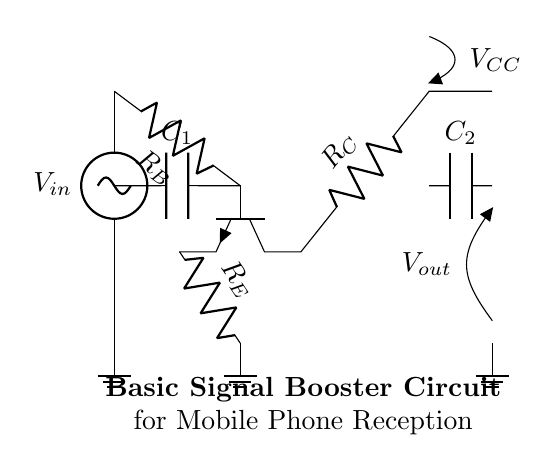What is the input voltage of the circuit? The input voltage, labeled as V_in, is shown at the top left of the circuit. It is the source of the signal entering the circuit.
Answer: V_in What type of transistor is used in this circuit? The circuit diagram shows an NPN transistor, which is indicated by the symbol drawn with a characteristic arrow on the emitter side.
Answer: NPN What are the biasing resistor values in this circuit? The biasing resistor values are marked as R_B and R_C on the diagram. R_B connects to the base of the transistor, while R_C connects to the collector.
Answer: R_B, R_C What is the purpose of capacitor C_1? Capacitor C_1 acts as a coupling capacitor, allowing AC signals to pass while blocking DC components. This means it effectively connects the input signal to the transistor's base.
Answer: Coupling How does the output voltage relate to the input voltage? The output voltage, labeled as V_out, is influenced by the amplification properties of the transistor. As an amplifier, it increases the signal amplitude relative to the input voltage based on the circuit design.
Answer: Amplified What is the function of the resistor R_E? Resistor R_E is used for stabilization and biasing in the circuit. It provides negative feedback, improving the linearity and overall performance of the amplifier.
Answer: Stabilization What is the purpose of the power supply voltage V_CC? V_CC is the supply voltage for the circuit, providing the necessary power for the transistor to operate and amplify the input signal.
Answer: Power supply 